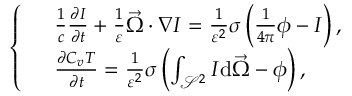<formula> <loc_0><loc_0><loc_500><loc_500>\left \{ \begin{array} { r l } & { \frac { 1 } { c } \frac { \partial I } { \partial t } + \frac { 1 } { \varepsilon } \vec { \Omega } \cdot \nabla I = \frac { 1 } { \varepsilon ^ { 2 } } \sigma \left ( \frac { 1 } { 4 \pi } \phi - I \right ) , } \\ & { \frac { \partial C _ { v } T } { \partial t } = \frac { 1 } { \varepsilon ^ { 2 } } \sigma \left ( \int _ { \mathcal { S } ^ { 2 } } I d \vec { \Omega } - \phi \right ) , } \end{array}</formula> 